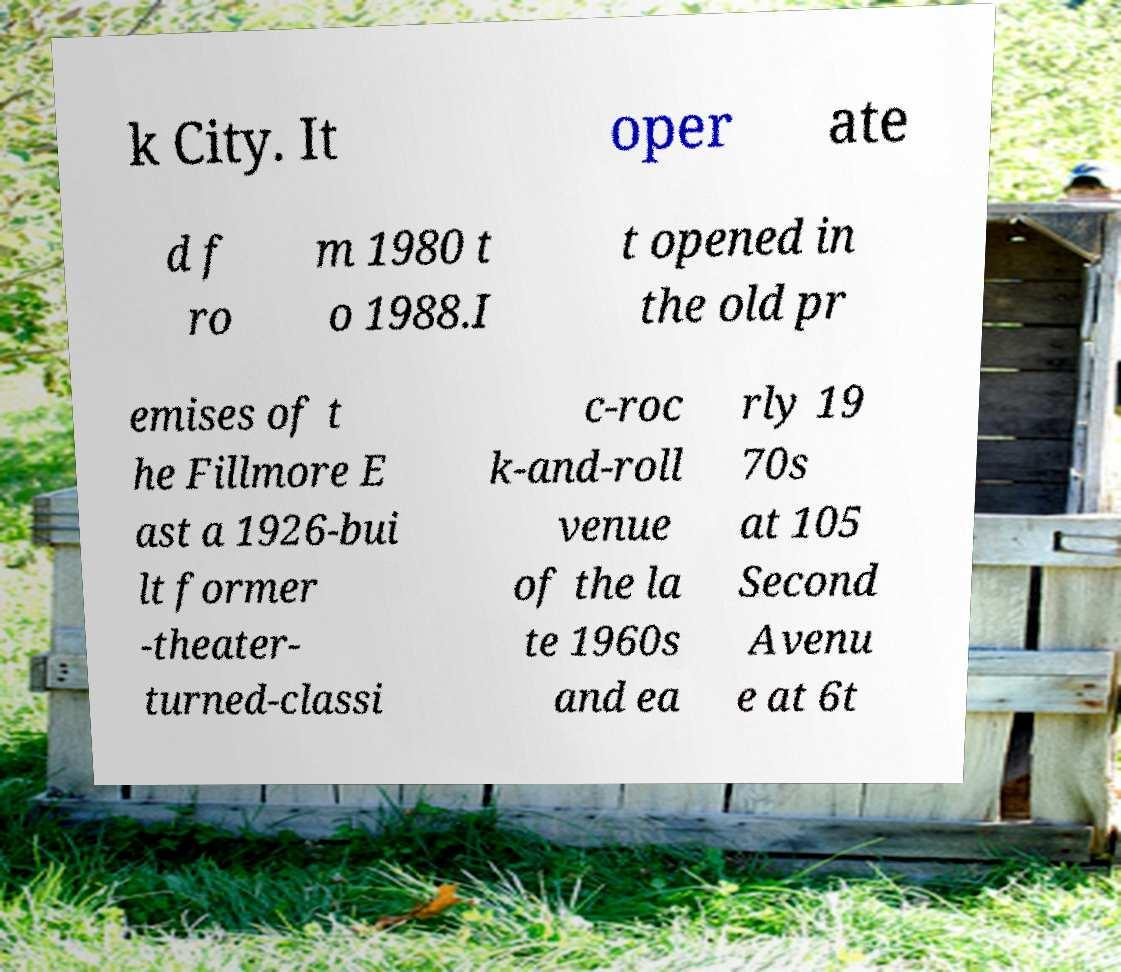Please read and relay the text visible in this image. What does it say? k City. It oper ate d f ro m 1980 t o 1988.I t opened in the old pr emises of t he Fillmore E ast a 1926-bui lt former -theater- turned-classi c-roc k-and-roll venue of the la te 1960s and ea rly 19 70s at 105 Second Avenu e at 6t 